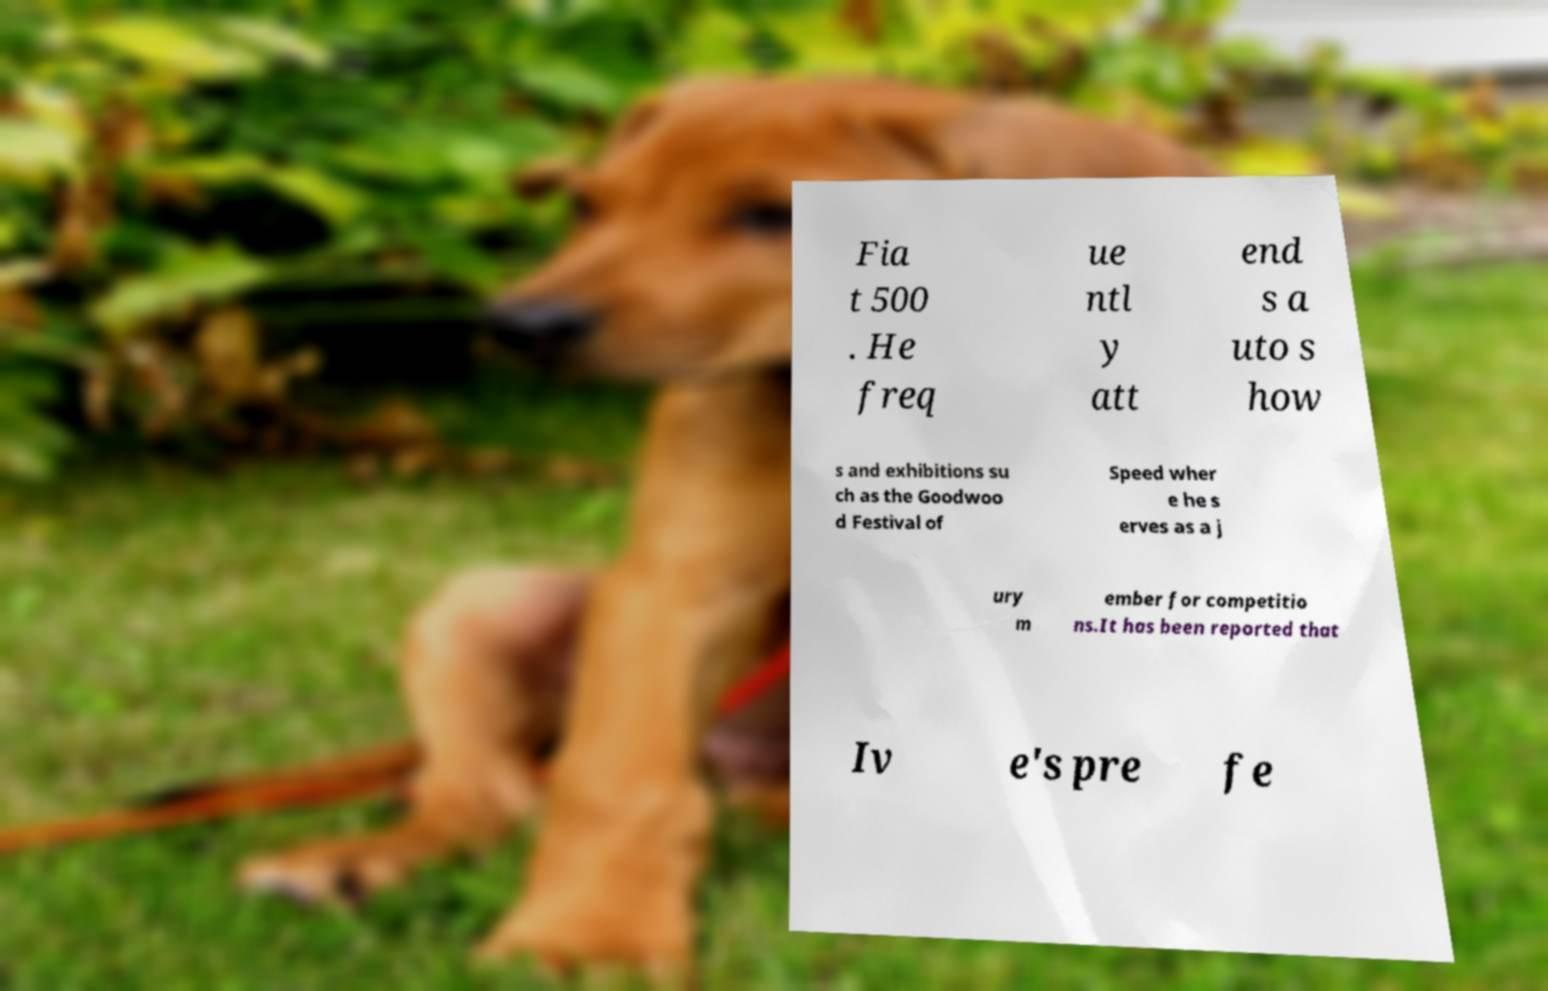Please identify and transcribe the text found in this image. Fia t 500 . He freq ue ntl y att end s a uto s how s and exhibitions su ch as the Goodwoo d Festival of Speed wher e he s erves as a j ury m ember for competitio ns.It has been reported that Iv e's pre fe 